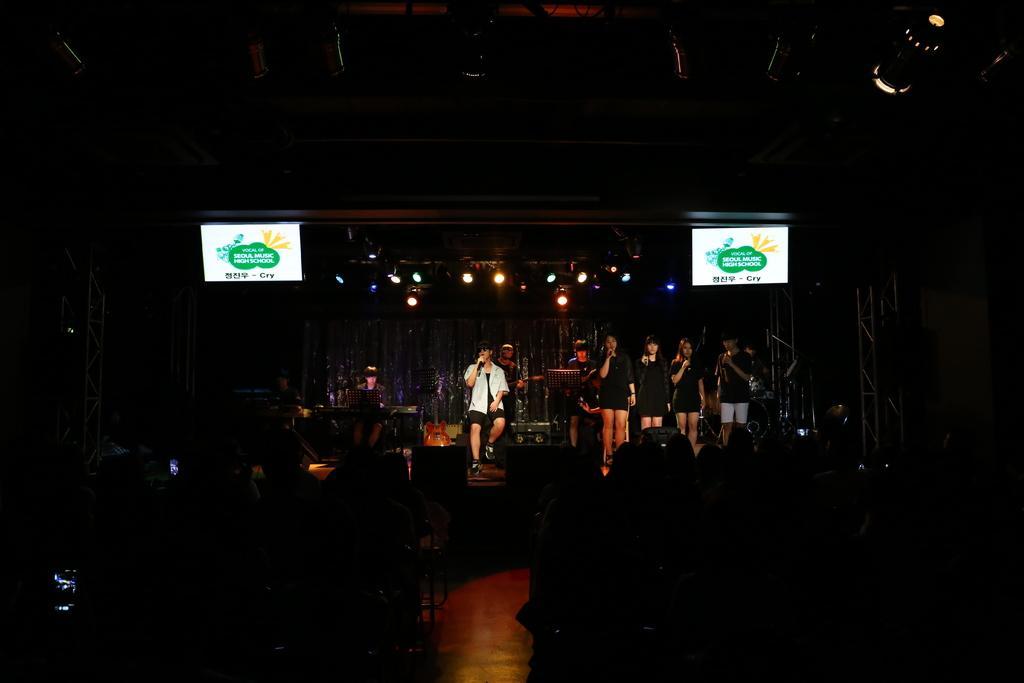How would you summarize this image in a sentence or two? At the bottom of the image there are few people sitting. In front of them there is a stage. On the stage there are few people sitting and few people are standing. Above them there are lights. 